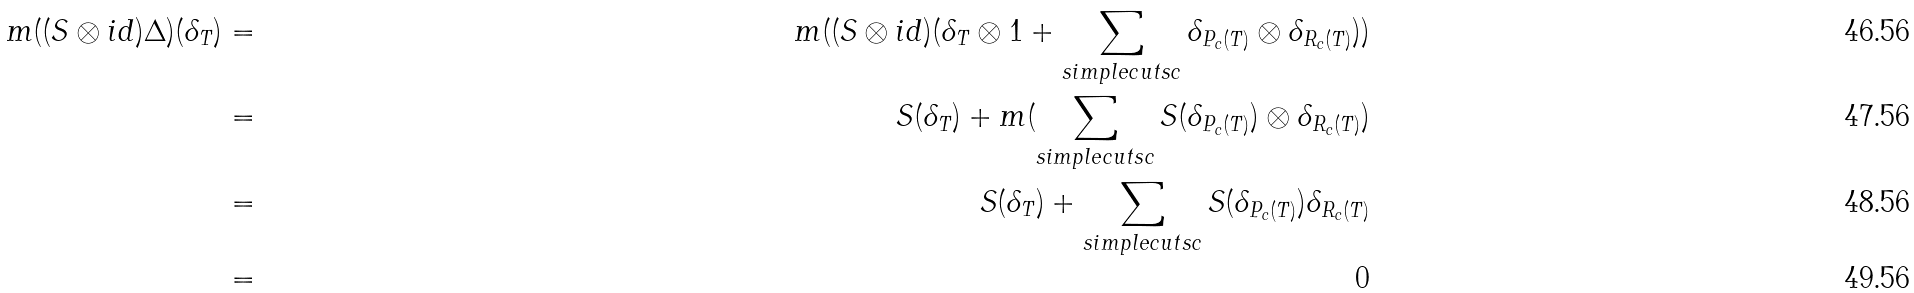<formula> <loc_0><loc_0><loc_500><loc_500>m ( ( S \otimes i d ) \Delta ) ( \delta _ { T } ) & = & m ( ( S \otimes i d ) ( \delta _ { T } \otimes 1 + \sum _ { s i m p l e c u t s c } \delta _ { P _ { c } ( T ) } \otimes \delta _ { R _ { c } ( T ) } ) ) \\ & = & S ( \delta _ { T } ) + m ( \sum _ { s i m p l e c u t s c } S ( \delta _ { P _ { c } ( T ) } ) \otimes \delta _ { R _ { c } ( T ) } ) \\ & = & S ( \delta _ { T } ) + \sum _ { s i m p l e c u t s c } S ( \delta _ { P _ { c } ( T ) } ) \delta _ { R _ { c } ( T ) } \\ & = & 0</formula> 